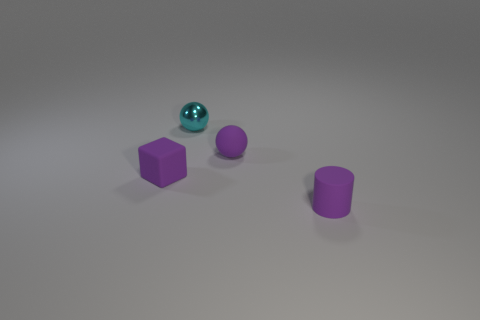What number of balls are either small purple objects or cyan metal things?
Provide a short and direct response. 2. There is a ball behind the small rubber thing that is behind the purple rubber cube; are there any small purple spheres in front of it?
Your answer should be very brief. Yes. There is another small object that is the same shape as the metallic thing; what is its color?
Your response must be concise. Purple. How many cyan things are either tiny spheres or small matte things?
Offer a terse response. 1. What is the material of the cyan thing that is behind the small purple rubber cube to the left of the purple rubber sphere?
Your answer should be compact. Metal. There is a rubber cylinder that is the same size as the purple rubber cube; what is its color?
Offer a terse response. Purple. Is there a small sphere that has the same color as the tiny rubber cylinder?
Your answer should be compact. Yes. Is there a tiny object?
Offer a terse response. Yes. Do the thing in front of the small matte block and the small cube have the same material?
Keep it short and to the point. Yes. What number of shiny balls are the same size as the cyan thing?
Make the answer very short. 0. 